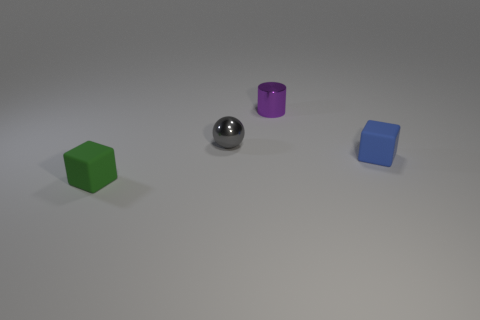Subtract all green cylinders. Subtract all gray blocks. How many cylinders are left? 1 Add 1 small blue cylinders. How many objects exist? 5 Subtract all cylinders. How many objects are left? 3 Add 4 red metallic cubes. How many red metallic cubes exist? 4 Subtract 0 brown cylinders. How many objects are left? 4 Subtract all green cubes. Subtract all yellow rubber cubes. How many objects are left? 3 Add 2 small gray metallic things. How many small gray metallic things are left? 3 